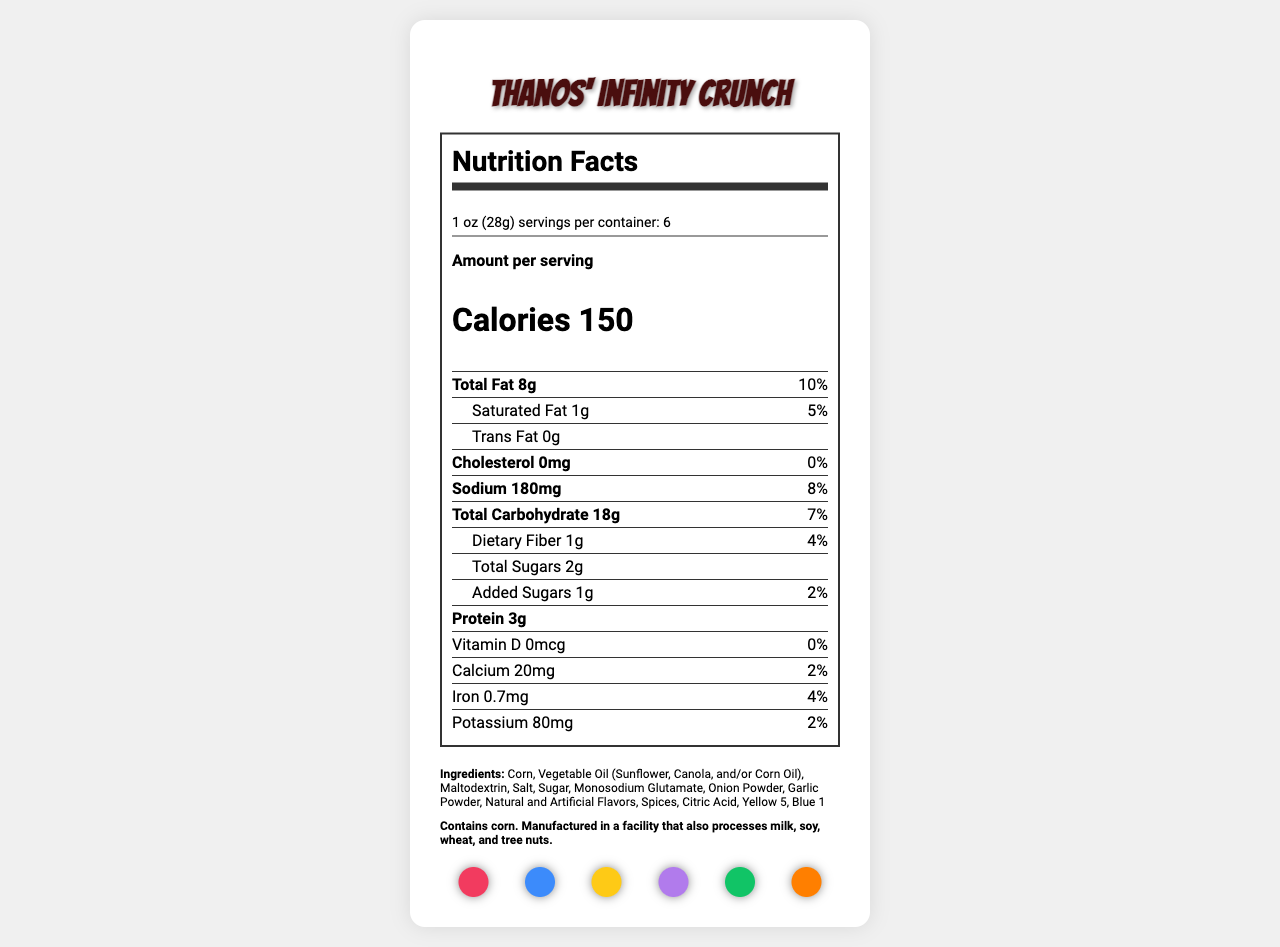what is the serving size of Thanos' Infinity Crunch? The serving size is explicitly stated under the product name in the document.
Answer: 1 oz (28g) how many calories are there per serving? The calorie content per serving is listed under the "Amount per serving" section.
Answer: 150 how much total fat is in each serving? The total fat for each serving is given in the nutrient section as "Total Fat 8g (10%)".
Answer: 8g how much sodium does one serving contain? Sodium content per serving is listed as 180mg with a daily value of 8%.
Answer: 180mg list the main ingredients of the snack. The main ingredients are listed in the "Ingredients" section of the document.
Answer: Corn, Vegetable Oil (Sunflower, Canola, and/or Corn Oil), Maltodextrin, Salt, Sugar, Monosodium Glutamate, Onion Powder, Garlic Powder, Natural and Artificial Flavors, Spices, Citric Acid, Yellow 5, Blue 1 which vitamin is not present in Thanos' Infinity Crunch? A. Vitamin A B. Vitamin C C. Vitamin D D. Vitamin E Vitamin D is listed as having 0mcg and 0% of the daily value.
Answer: C what is the percentage daily value of saturated fat per serving? A. 1% B. 3% C. 5% D. 10% The daily value for saturated fat per serving is provided as 5%.
Answer: C is the product suitable for people with a corn allergy? The allergen information clearly states, "Contains corn."
Answer: No summarize the nutritional content of Thanos' Infinity Crunch in one sentence. This summary captures the key nutritional elements listed on the document.
Answer: Thanos' Infinity Crunch is a snack with 150 calories per serving, consisting of 8g of total fat, 180mg of sodium, 18g of carbohydrates, and 3g of protein, along with several vitamins and minerals in trace amounts. what is the primary theme of the snack's marketing? The snack is marketed around Thanos, a popular comic book and movie villain, as seen in the product name and theme-related marketing points.
Answer: Comic book villain-themed (Thanos) identify any artificial colors used in the product. The ingredients list includes "Yellow 5" and "Blue 1" which are artificial colors.
Answer: Yellow 5, Blue 1 how does the serving size of this snack compare to a typical bag of chips? The document does not provide information on typical bag sizes for comparison.
Answer: Cannot be determined is there any cholesterol in Thanos' Infinity Crunch? Cholesterol is listed as 0mg (0% Daily Value) in the nutritional facts.
Answer: No what could be a potential consumer perception impact of using a villain-themed snack? This is inferred from critical analysis points discussing the marketing strategy of using a villain-themed snack.
Answer: It might attract comic book fans and moviegoers who are fans of Thanos, but could also potentially deter consumers who prefer positive character endorsements. 